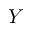<formula> <loc_0><loc_0><loc_500><loc_500>Y</formula> 